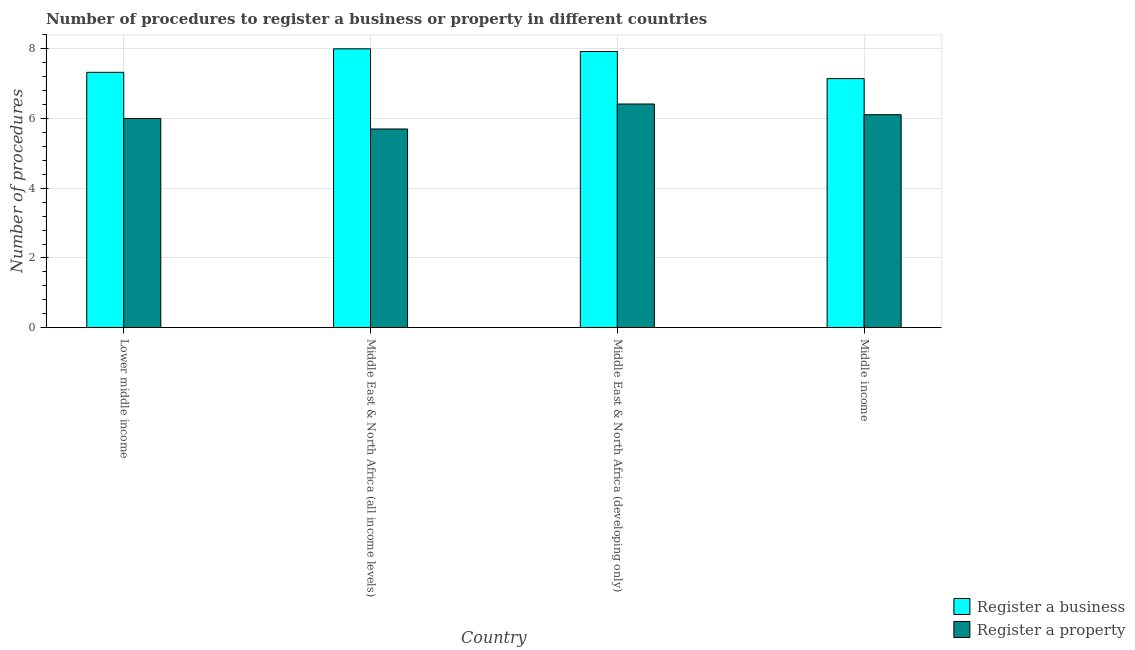How many different coloured bars are there?
Your answer should be very brief. 2. How many bars are there on the 3rd tick from the left?
Your answer should be compact. 2. How many bars are there on the 4th tick from the right?
Your answer should be very brief. 2. What is the label of the 1st group of bars from the left?
Your response must be concise. Lower middle income. In how many cases, is the number of bars for a given country not equal to the number of legend labels?
Provide a succinct answer. 0. What is the number of procedures to register a property in Lower middle income?
Your response must be concise. 6. Across all countries, what is the minimum number of procedures to register a business?
Offer a terse response. 7.15. In which country was the number of procedures to register a business maximum?
Give a very brief answer. Middle East & North Africa (all income levels). In which country was the number of procedures to register a property minimum?
Offer a very short reply. Middle East & North Africa (all income levels). What is the total number of procedures to register a property in the graph?
Offer a terse response. 24.23. What is the difference between the number of procedures to register a business in Lower middle income and that in Middle East & North Africa (developing only)?
Ensure brevity in your answer.  -0.6. What is the difference between the number of procedures to register a property in Middle East & North Africa (developing only) and the number of procedures to register a business in Middle East & North Africa (all income levels)?
Make the answer very short. -1.58. What is the average number of procedures to register a business per country?
Your answer should be compact. 7.6. What is the difference between the number of procedures to register a business and number of procedures to register a property in Middle income?
Provide a short and direct response. 1.04. What is the ratio of the number of procedures to register a property in Middle East & North Africa (developing only) to that in Middle income?
Provide a succinct answer. 1.05. What is the difference between the highest and the second highest number of procedures to register a property?
Make the answer very short. 0.31. What is the difference between the highest and the lowest number of procedures to register a business?
Ensure brevity in your answer.  0.85. In how many countries, is the number of procedures to register a property greater than the average number of procedures to register a property taken over all countries?
Your answer should be compact. 2. Is the sum of the number of procedures to register a property in Lower middle income and Middle East & North Africa (developing only) greater than the maximum number of procedures to register a business across all countries?
Your answer should be compact. Yes. What does the 1st bar from the left in Middle income represents?
Give a very brief answer. Register a business. What does the 2nd bar from the right in Middle income represents?
Your answer should be very brief. Register a business. How many bars are there?
Your answer should be very brief. 8. How many countries are there in the graph?
Make the answer very short. 4. What is the difference between two consecutive major ticks on the Y-axis?
Ensure brevity in your answer.  2. Are the values on the major ticks of Y-axis written in scientific E-notation?
Your answer should be very brief. No. Does the graph contain grids?
Your response must be concise. Yes. How are the legend labels stacked?
Offer a terse response. Vertical. What is the title of the graph?
Offer a terse response. Number of procedures to register a business or property in different countries. What is the label or title of the Y-axis?
Your response must be concise. Number of procedures. What is the Number of procedures in Register a business in Lower middle income?
Offer a very short reply. 7.33. What is the Number of procedures of Register a property in Lower middle income?
Provide a short and direct response. 6. What is the Number of procedures in Register a property in Middle East & North Africa (all income levels)?
Give a very brief answer. 5.7. What is the Number of procedures of Register a business in Middle East & North Africa (developing only)?
Provide a succinct answer. 7.92. What is the Number of procedures in Register a property in Middle East & North Africa (developing only)?
Offer a very short reply. 6.42. What is the Number of procedures in Register a business in Middle income?
Offer a terse response. 7.15. What is the Number of procedures of Register a property in Middle income?
Your answer should be very brief. 6.11. Across all countries, what is the maximum Number of procedures in Register a business?
Offer a terse response. 8. Across all countries, what is the maximum Number of procedures in Register a property?
Ensure brevity in your answer.  6.42. Across all countries, what is the minimum Number of procedures of Register a business?
Provide a succinct answer. 7.15. What is the total Number of procedures in Register a business in the graph?
Your response must be concise. 30.39. What is the total Number of procedures in Register a property in the graph?
Offer a very short reply. 24.23. What is the difference between the Number of procedures in Register a business in Lower middle income and that in Middle East & North Africa (all income levels)?
Ensure brevity in your answer.  -0.67. What is the difference between the Number of procedures of Register a property in Lower middle income and that in Middle East & North Africa (all income levels)?
Make the answer very short. 0.3. What is the difference between the Number of procedures of Register a business in Lower middle income and that in Middle East & North Africa (developing only)?
Your response must be concise. -0.6. What is the difference between the Number of procedures of Register a property in Lower middle income and that in Middle East & North Africa (developing only)?
Your answer should be very brief. -0.41. What is the difference between the Number of procedures of Register a business in Lower middle income and that in Middle income?
Give a very brief answer. 0.18. What is the difference between the Number of procedures of Register a property in Lower middle income and that in Middle income?
Your response must be concise. -0.11. What is the difference between the Number of procedures in Register a business in Middle East & North Africa (all income levels) and that in Middle East & North Africa (developing only)?
Ensure brevity in your answer.  0.08. What is the difference between the Number of procedures in Register a property in Middle East & North Africa (all income levels) and that in Middle East & North Africa (developing only)?
Keep it short and to the point. -0.72. What is the difference between the Number of procedures of Register a business in Middle East & North Africa (all income levels) and that in Middle income?
Your response must be concise. 0.85. What is the difference between the Number of procedures in Register a property in Middle East & North Africa (all income levels) and that in Middle income?
Offer a very short reply. -0.41. What is the difference between the Number of procedures in Register a business in Middle East & North Africa (developing only) and that in Middle income?
Give a very brief answer. 0.78. What is the difference between the Number of procedures of Register a property in Middle East & North Africa (developing only) and that in Middle income?
Ensure brevity in your answer.  0.31. What is the difference between the Number of procedures of Register a business in Lower middle income and the Number of procedures of Register a property in Middle East & North Africa (all income levels)?
Provide a succinct answer. 1.63. What is the difference between the Number of procedures of Register a business in Lower middle income and the Number of procedures of Register a property in Middle East & North Africa (developing only)?
Your response must be concise. 0.91. What is the difference between the Number of procedures in Register a business in Lower middle income and the Number of procedures in Register a property in Middle income?
Your answer should be compact. 1.22. What is the difference between the Number of procedures of Register a business in Middle East & North Africa (all income levels) and the Number of procedures of Register a property in Middle East & North Africa (developing only)?
Give a very brief answer. 1.58. What is the difference between the Number of procedures in Register a business in Middle East & North Africa (all income levels) and the Number of procedures in Register a property in Middle income?
Offer a terse response. 1.89. What is the difference between the Number of procedures in Register a business in Middle East & North Africa (developing only) and the Number of procedures in Register a property in Middle income?
Keep it short and to the point. 1.81. What is the average Number of procedures in Register a business per country?
Provide a short and direct response. 7.6. What is the average Number of procedures in Register a property per country?
Make the answer very short. 6.06. What is the difference between the Number of procedures in Register a business and Number of procedures in Register a property in Lower middle income?
Your answer should be very brief. 1.32. What is the difference between the Number of procedures of Register a business and Number of procedures of Register a property in Middle East & North Africa (developing only)?
Your answer should be compact. 1.51. What is the difference between the Number of procedures in Register a business and Number of procedures in Register a property in Middle income?
Give a very brief answer. 1.04. What is the ratio of the Number of procedures of Register a business in Lower middle income to that in Middle East & North Africa (all income levels)?
Provide a succinct answer. 0.92. What is the ratio of the Number of procedures in Register a property in Lower middle income to that in Middle East & North Africa (all income levels)?
Make the answer very short. 1.05. What is the ratio of the Number of procedures in Register a business in Lower middle income to that in Middle East & North Africa (developing only)?
Provide a succinct answer. 0.92. What is the ratio of the Number of procedures of Register a property in Lower middle income to that in Middle East & North Africa (developing only)?
Offer a very short reply. 0.94. What is the ratio of the Number of procedures of Register a business in Lower middle income to that in Middle income?
Offer a terse response. 1.03. What is the ratio of the Number of procedures of Register a property in Lower middle income to that in Middle income?
Offer a terse response. 0.98. What is the ratio of the Number of procedures of Register a business in Middle East & North Africa (all income levels) to that in Middle East & North Africa (developing only)?
Keep it short and to the point. 1.01. What is the ratio of the Number of procedures of Register a property in Middle East & North Africa (all income levels) to that in Middle East & North Africa (developing only)?
Provide a succinct answer. 0.89. What is the ratio of the Number of procedures of Register a business in Middle East & North Africa (all income levels) to that in Middle income?
Your response must be concise. 1.12. What is the ratio of the Number of procedures in Register a property in Middle East & North Africa (all income levels) to that in Middle income?
Provide a short and direct response. 0.93. What is the ratio of the Number of procedures of Register a business in Middle East & North Africa (developing only) to that in Middle income?
Make the answer very short. 1.11. What is the ratio of the Number of procedures of Register a property in Middle East & North Africa (developing only) to that in Middle income?
Keep it short and to the point. 1.05. What is the difference between the highest and the second highest Number of procedures of Register a business?
Provide a succinct answer. 0.08. What is the difference between the highest and the second highest Number of procedures in Register a property?
Offer a terse response. 0.31. What is the difference between the highest and the lowest Number of procedures in Register a business?
Make the answer very short. 0.85. What is the difference between the highest and the lowest Number of procedures in Register a property?
Your response must be concise. 0.72. 